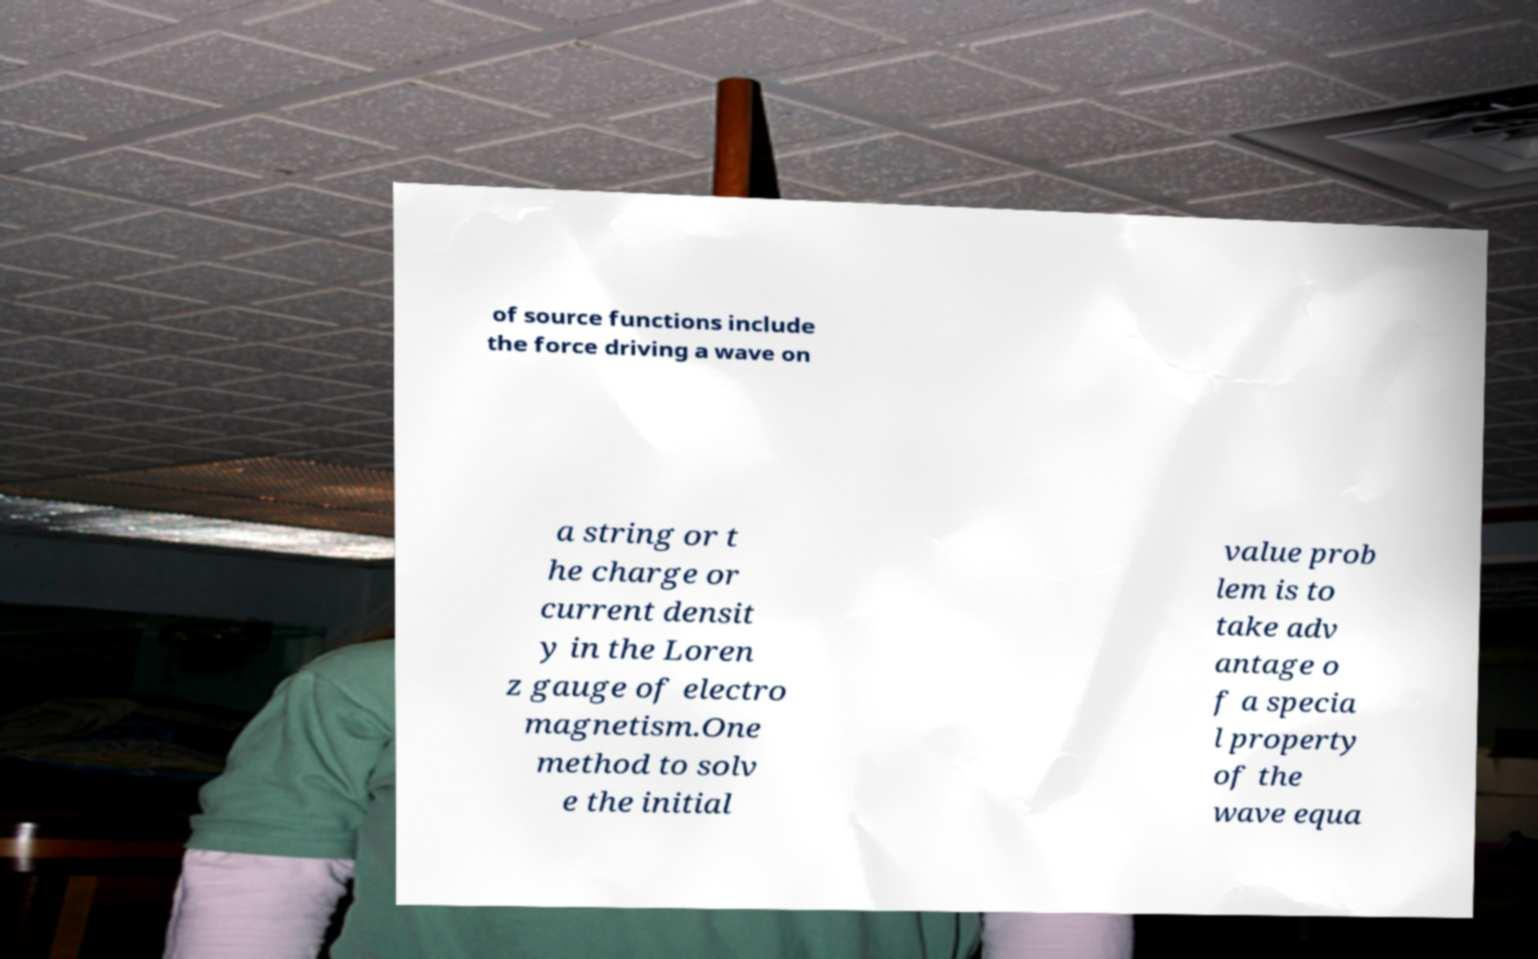Can you accurately transcribe the text from the provided image for me? of source functions include the force driving a wave on a string or t he charge or current densit y in the Loren z gauge of electro magnetism.One method to solv e the initial value prob lem is to take adv antage o f a specia l property of the wave equa 